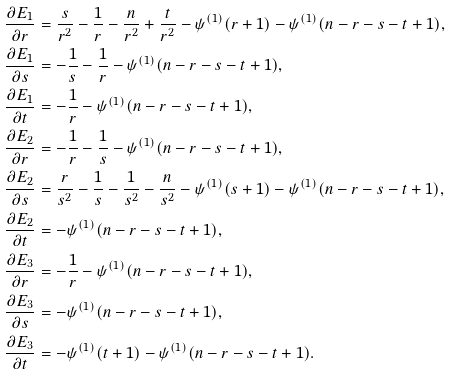<formula> <loc_0><loc_0><loc_500><loc_500>\frac { \partial E _ { 1 } } { \partial r } & = \frac { s } { r ^ { 2 } } - \frac { 1 } { r } - \frac { n } { r ^ { 2 } } + \frac { t } { r ^ { 2 } } - \psi ^ { ( 1 ) } ( r + 1 ) - \psi ^ { ( 1 ) } ( n - r - s - t + 1 ) , \\ \frac { \partial E _ { 1 } } { \partial s } & = - \frac { 1 } { s } - \frac { 1 } { r } - \psi ^ { ( 1 ) } ( n - r - s - t + 1 ) , \\ \frac { \partial E _ { 1 } } { \partial t } & = - \frac { 1 } { r } - \psi ^ { ( 1 ) } ( n - r - s - t + 1 ) , \\ \frac { \partial E _ { 2 } } { \partial r } & = - \frac { 1 } { r } - \frac { 1 } { s } - \psi ^ { ( 1 ) } ( n - r - s - t + 1 ) , \\ \frac { \partial E _ { 2 } } { \partial s } & = \frac { r } { s ^ { 2 } } - \frac { 1 } { s } - \frac { 1 } { s ^ { 2 } } - \frac { n } { s ^ { 2 } } - \psi ^ { ( 1 ) } ( s + 1 ) - \psi ^ { ( 1 ) } ( n - r - s - t + 1 ) , \\ \frac { \partial E _ { 2 } } { \partial t } & = - \psi ^ { ( 1 ) } ( n - r - s - t + 1 ) , \\ \frac { \partial E _ { 3 } } { \partial r } & = - \frac { 1 } { r } - \psi ^ { ( 1 ) } ( n - r - s - t + 1 ) , \\ \frac { \partial E _ { 3 } } { \partial s } & = - \psi ^ { ( 1 ) } ( n - r - s - t + 1 ) , \\ \frac { \partial E _ { 3 } } { \partial t } & = - \psi ^ { ( 1 ) } ( t + 1 ) - \psi ^ { ( 1 ) } ( n - r - s - t + 1 ) .</formula> 